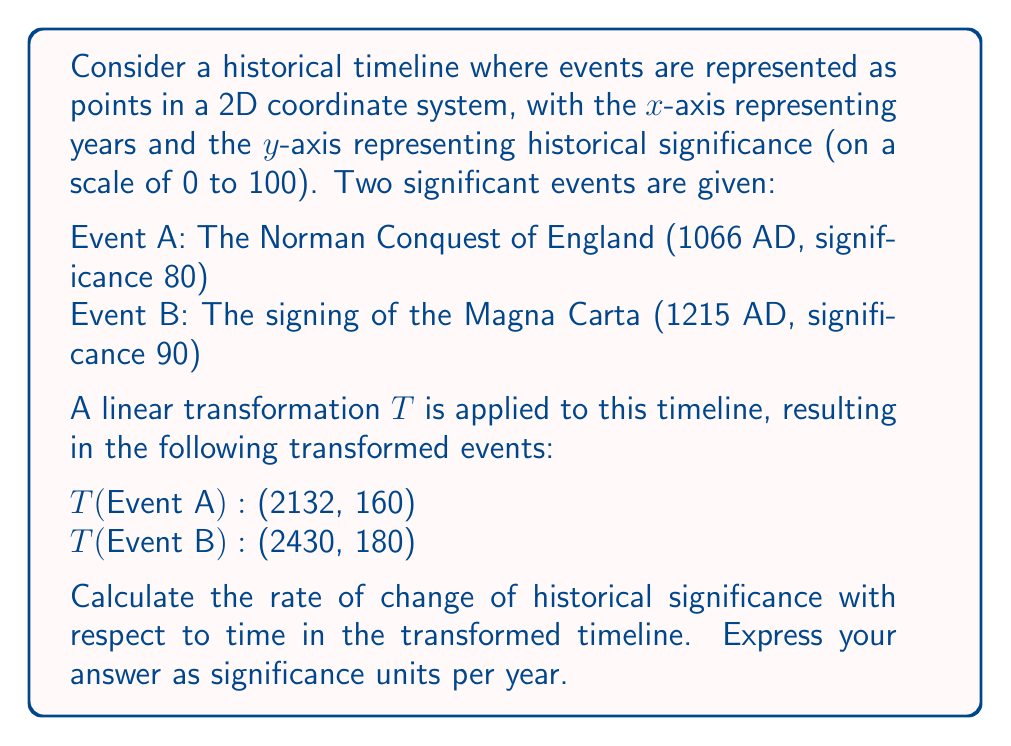Show me your answer to this math problem. To solve this problem, we'll follow these steps:

1) First, let's identify the original and transformed coordinates:
   Event A: (1066, 80) → (2132, 160)
   Event B: (1215, 90) → (2430, 180)

2) The rate of change of significance with respect to time is essentially the slope of the line connecting these points in the transformed space. We can calculate this using the slope formula:

   $$ m = \frac{y_2 - y_1}{x_2 - x_1} $$

   where $(x_1, y_1)$ is the transformed Event A and $(x_2, y_2)$ is the transformed Event B.

3) Let's plug in the values:

   $$ m = \frac{180 - 160}{2430 - 2132} $$

4) Simplify:

   $$ m = \frac{20}{298} $$

5) Divide:

   $$ m \approx 0.0671 $$

This result means that for each year that passes in the transformed timeline, the historical significance increases by approximately 0.0671 units.

Note: As a history student, you might find it interesting that this linear transformation has not only stretched the timeline but has also amplified the significance of events. This could represent how certain historical periods gain more importance or attention over time in historical studies.
Answer: The rate of change of historical significance with respect to time in the transformed timeline is approximately 0.0671 significance units per year. 